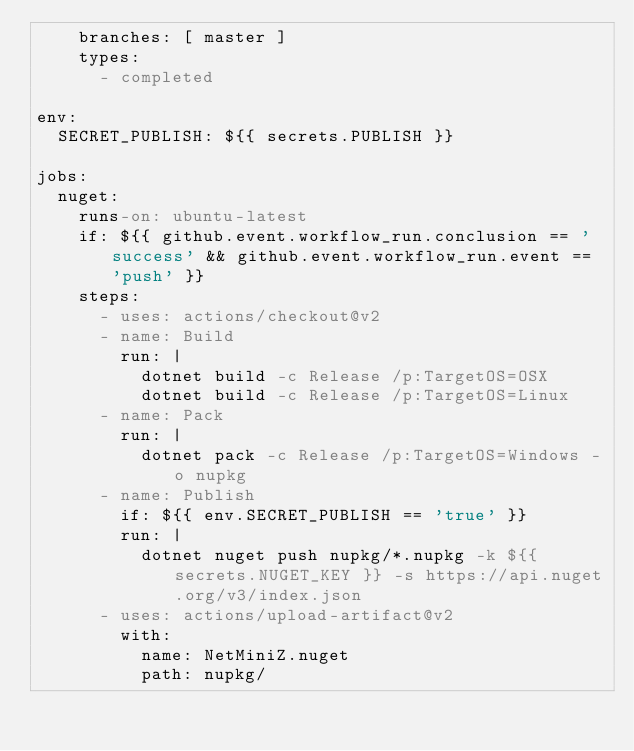<code> <loc_0><loc_0><loc_500><loc_500><_YAML_>    branches: [ master ]
    types:
      - completed

env:
  SECRET_PUBLISH: ${{ secrets.PUBLISH }}

jobs:
  nuget:
    runs-on: ubuntu-latest
    if: ${{ github.event.workflow_run.conclusion == 'success' && github.event.workflow_run.event == 'push' }}
    steps:
      - uses: actions/checkout@v2
      - name: Build
        run: |
          dotnet build -c Release /p:TargetOS=OSX
          dotnet build -c Release /p:TargetOS=Linux
      - name: Pack
        run: |
          dotnet pack -c Release /p:TargetOS=Windows -o nupkg
      - name: Publish
        if: ${{ env.SECRET_PUBLISH == 'true' }}
        run: |
          dotnet nuget push nupkg/*.nupkg -k ${{ secrets.NUGET_KEY }} -s https://api.nuget.org/v3/index.json
      - uses: actions/upload-artifact@v2
        with: 
          name: NetMiniZ.nuget
          path: nupkg/
</code> 